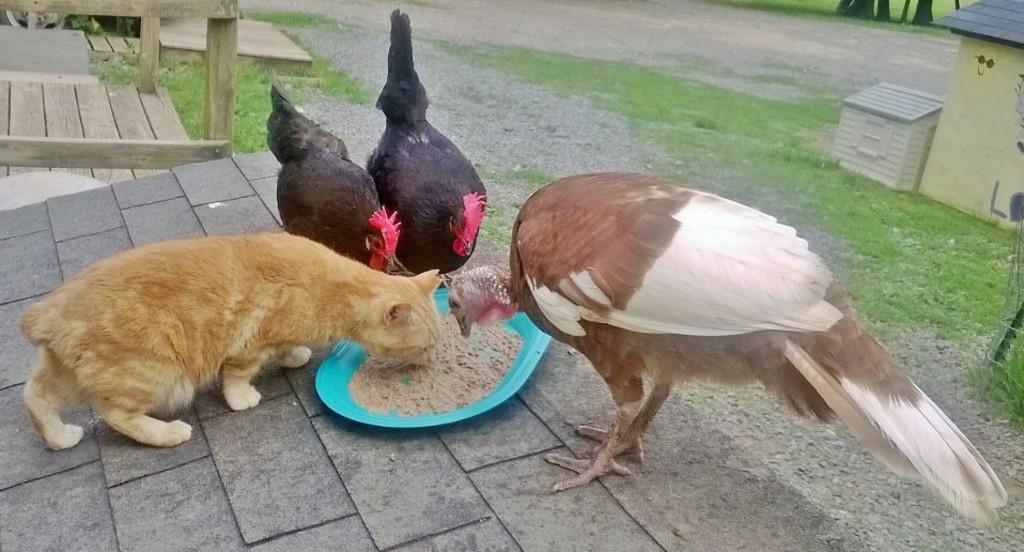In one or two sentences, can you explain what this image depicts? In this image there is a cat, two hens and a bird eating food from a plate, behind them there is grass and wooden stairs. 